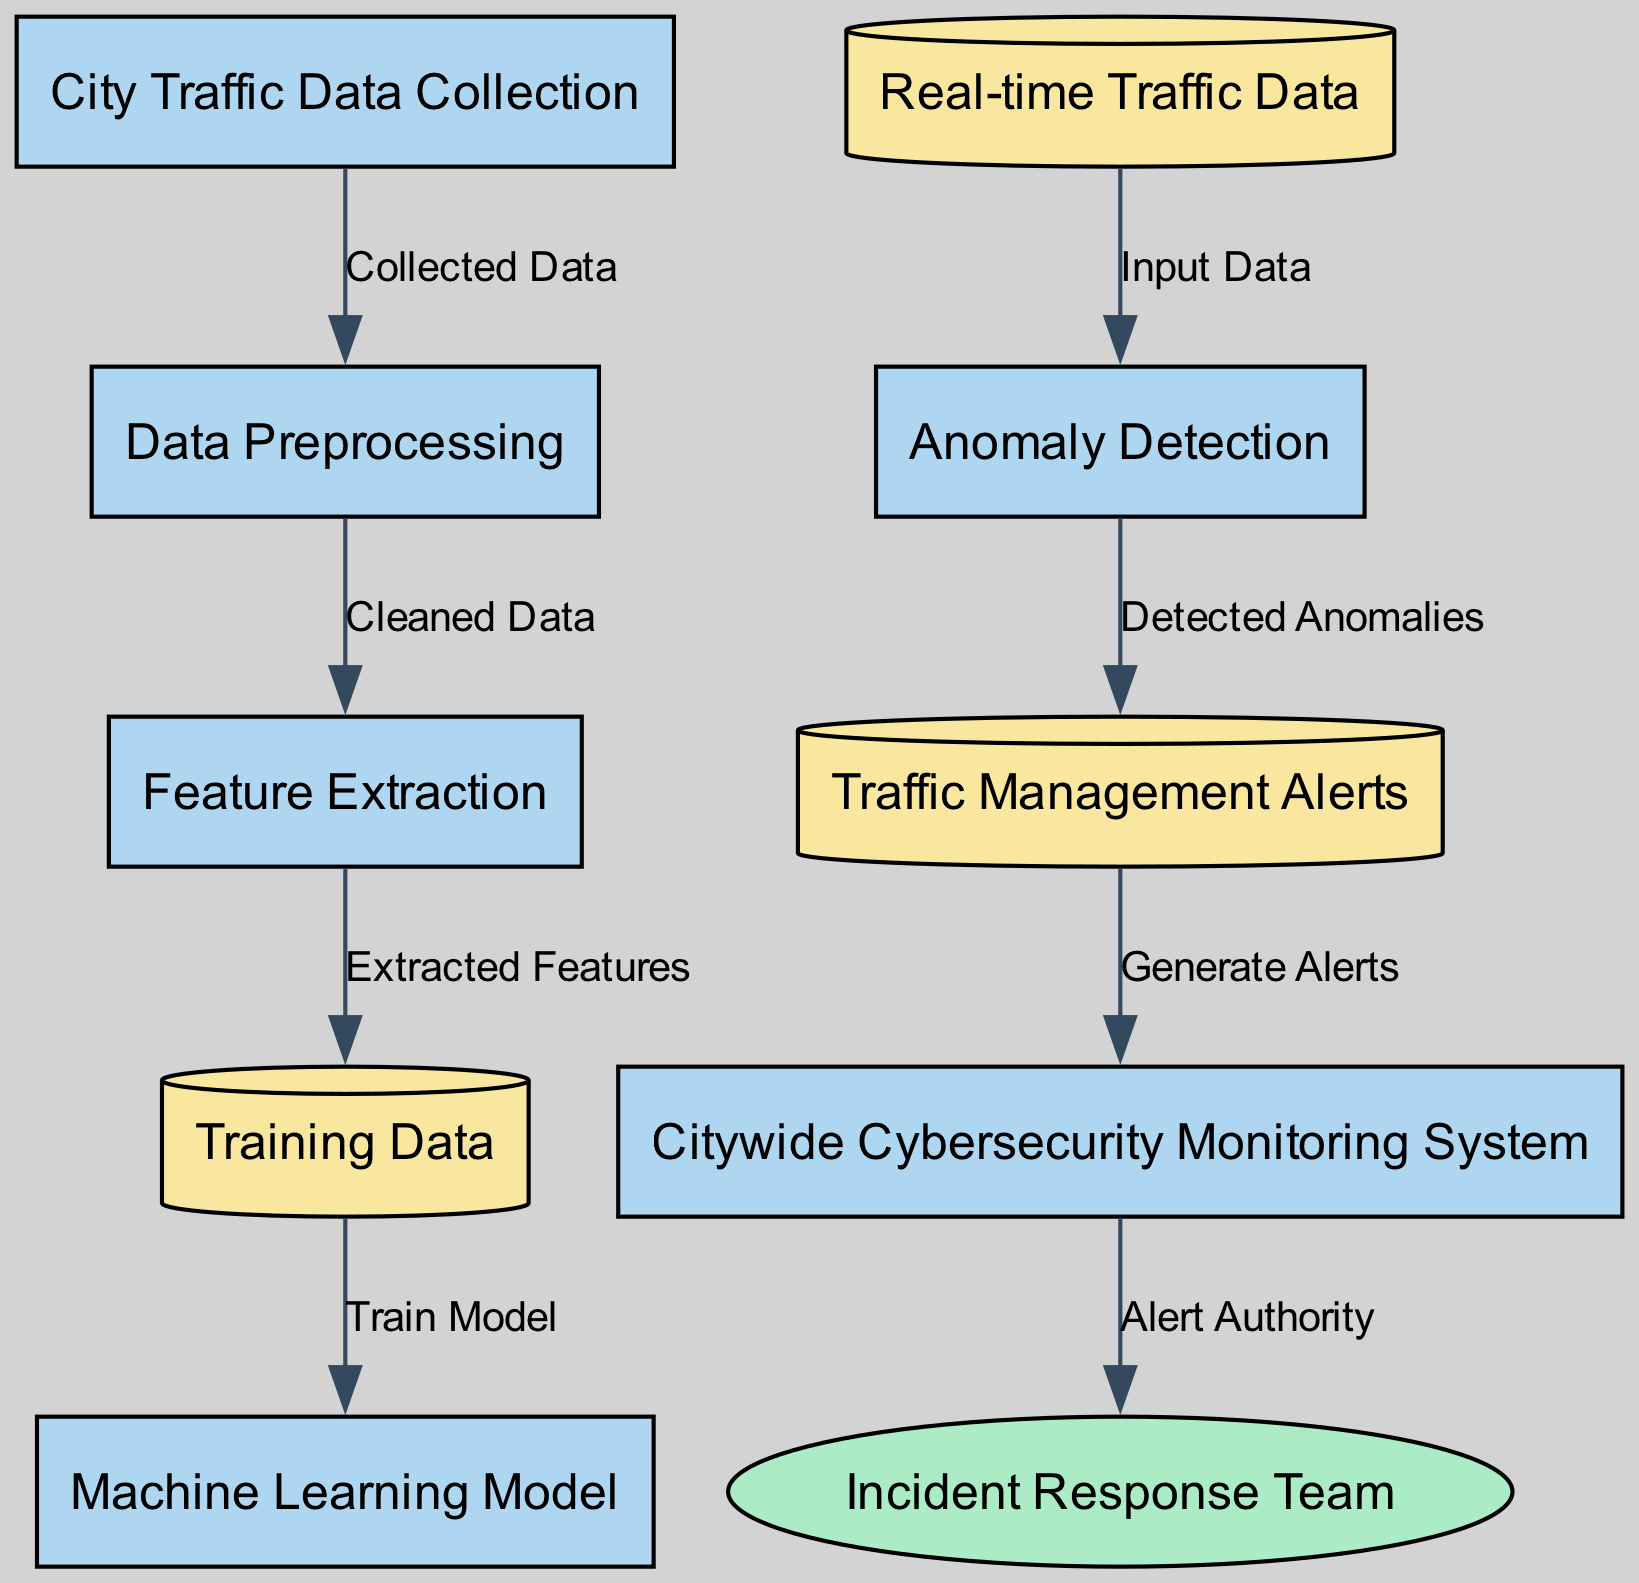What is the first process in the diagram? The first process node listed in the diagram is "City Traffic Data Collection". This is the starting point where the data is collected before further processing.
Answer: City Traffic Data Collection How many data nodes are there in the diagram? There are three data nodes in the diagram: "Training Data," "Real-time Traffic Data," and "Traffic Management Alerts." Each represents different stages of data handling.
Answer: 3 Which process generates alerts for the incident response team? The process "Citywide Cybersecurity Monitoring System" generates alerts for the incident response team. It is connected directly to the "Traffic Management Alerts" data node.
Answer: Citywide Cybersecurity Monitoring System What type of data is "Training Data"? "Training Data" is classified as a data node in the diagram, indicating it is a specific type of information being utilized for model training in the machine learning process.
Answer: data What is the relationship between "Real-time Traffic Data" and "Anomaly Detection"? The relationship is that "Real-time Traffic Data" serves as input data for the "Anomaly Detection" process, indicating that the real-time data is used to identify anomalies.
Answer: Input Data Which process comes after "Feature Extraction"? The process that comes after "Feature Extraction" is "Training Data." This indicates that the features extracted from the data are used to create a training set for the model.
Answer: Training Data How are "Detected Anomalies" processed in the diagram? "Detected Anomalies" are a result of the "Anomaly Detection" process, and they are processed into alerts generated in the "Traffic Management Alerts" data node. This shows how detected issues are communicated further.
Answer: Generate Alerts What is the final output of the diagram? The final output is alerts that are communicated to the "Incident Response Team," indicating that the entire process leads to notifying the appropriate team based on detected anomalies.
Answer: Incident Response Team 